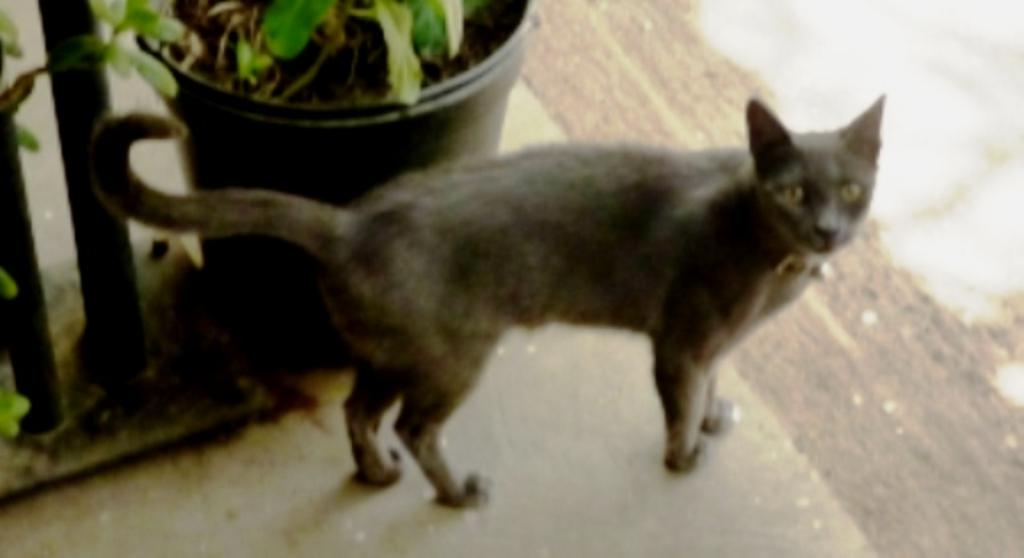What type of animal is in the image? There is a cat in the image. Where is the cat positioned in the image? The cat is standing on the floor. What other object is present in the image? There is a pot plant in the image. How is the pot plant situated in relation to the cat? The pot plant is beside the cat. What time of day is it in the image, and how does the cat's cough sound? The time of day is not mentioned in the image, and there is no indication that the cat is coughing. 